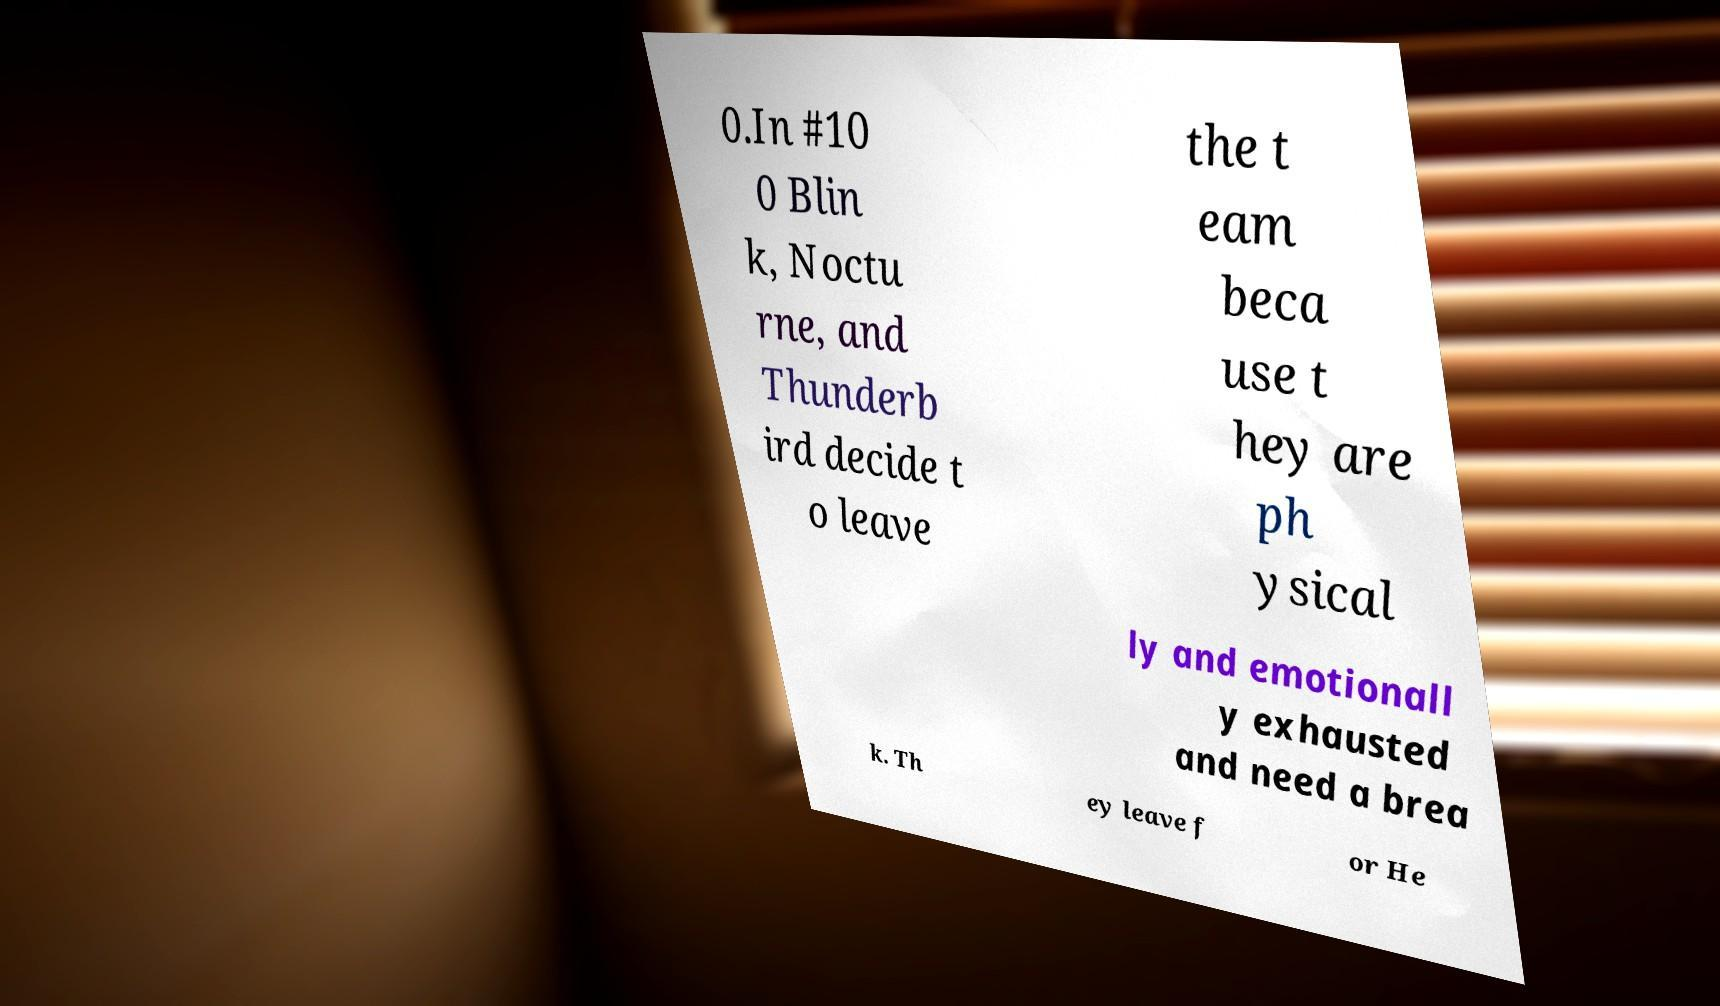Please read and relay the text visible in this image. What does it say? 0.In #10 0 Blin k, Noctu rne, and Thunderb ird decide t o leave the t eam beca use t hey are ph ysical ly and emotionall y exhausted and need a brea k. Th ey leave f or He 